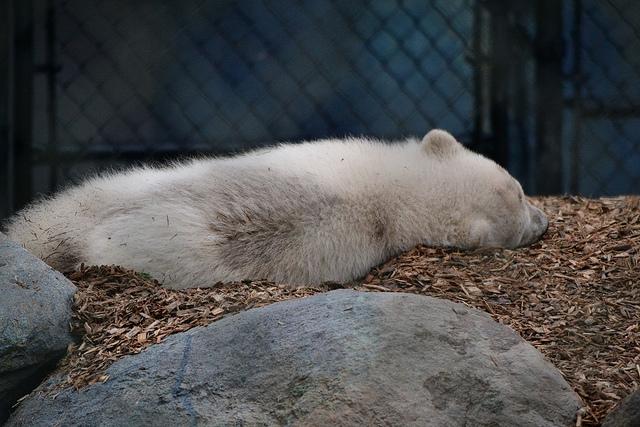Is this animal roaming around?
Quick response, please. No. What kind of animal is laying in the hay?
Keep it brief. Bear. What kind of animal is this?
Be succinct. Polar bear. Is this type of bedding natural to this bear's usual habitat?
Concise answer only. No. 